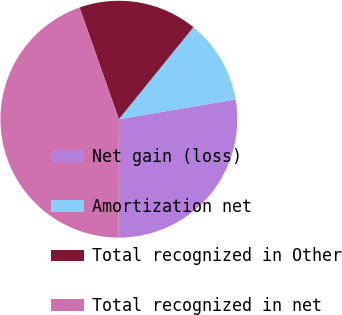<chart> <loc_0><loc_0><loc_500><loc_500><pie_chart><fcel>Net gain (loss)<fcel>Amortization net<fcel>Total recognized in Other<fcel>Total recognized in net<nl><fcel>27.7%<fcel>11.49%<fcel>16.22%<fcel>44.59%<nl></chart> 